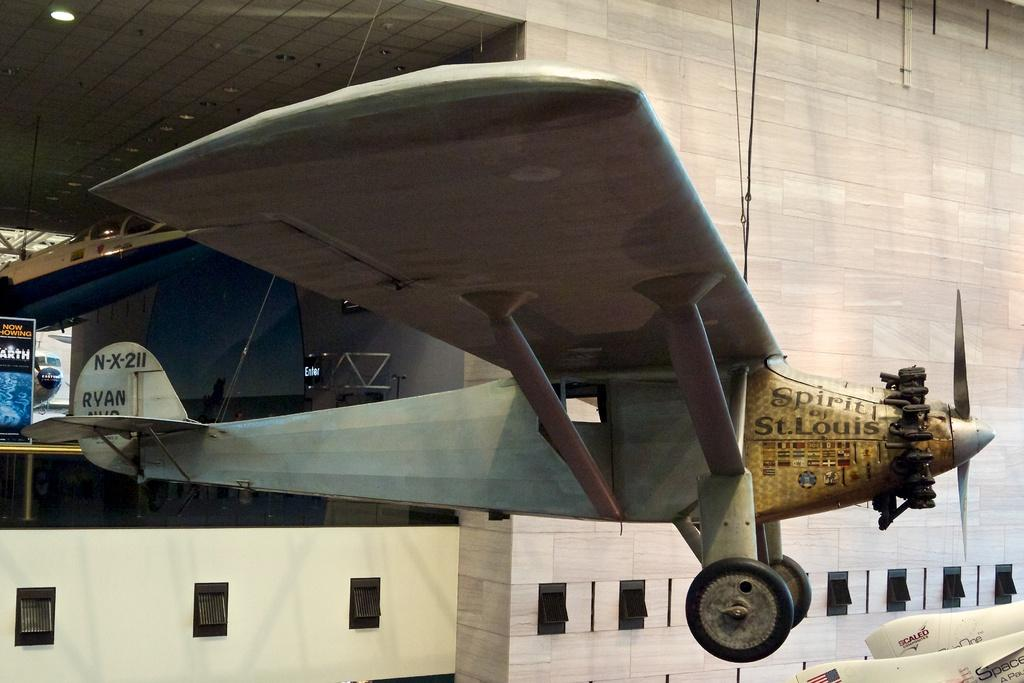<image>
Relay a brief, clear account of the picture shown. The Spirit of St. Louis airplane is displayed hanging from the ceiling. 